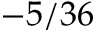<formula> <loc_0><loc_0><loc_500><loc_500>- 5 / 3 6</formula> 